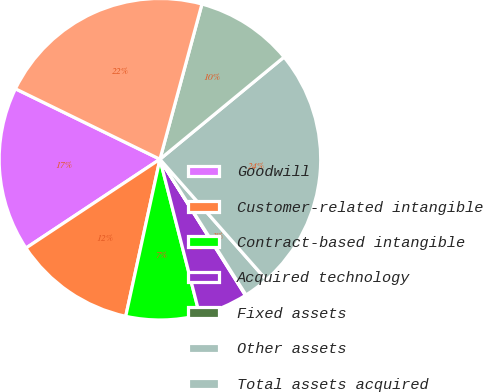<chart> <loc_0><loc_0><loc_500><loc_500><pie_chart><fcel>Goodwill<fcel>Customer-related intangible<fcel>Contract-based intangible<fcel>Acquired technology<fcel>Fixed assets<fcel>Other assets<fcel>Total assets acquired<fcel>Deferred income taxes<fcel>Net assets acquired<nl><fcel>16.54%<fcel>12.27%<fcel>7.39%<fcel>4.95%<fcel>0.07%<fcel>2.51%<fcel>24.46%<fcel>9.83%<fcel>21.99%<nl></chart> 